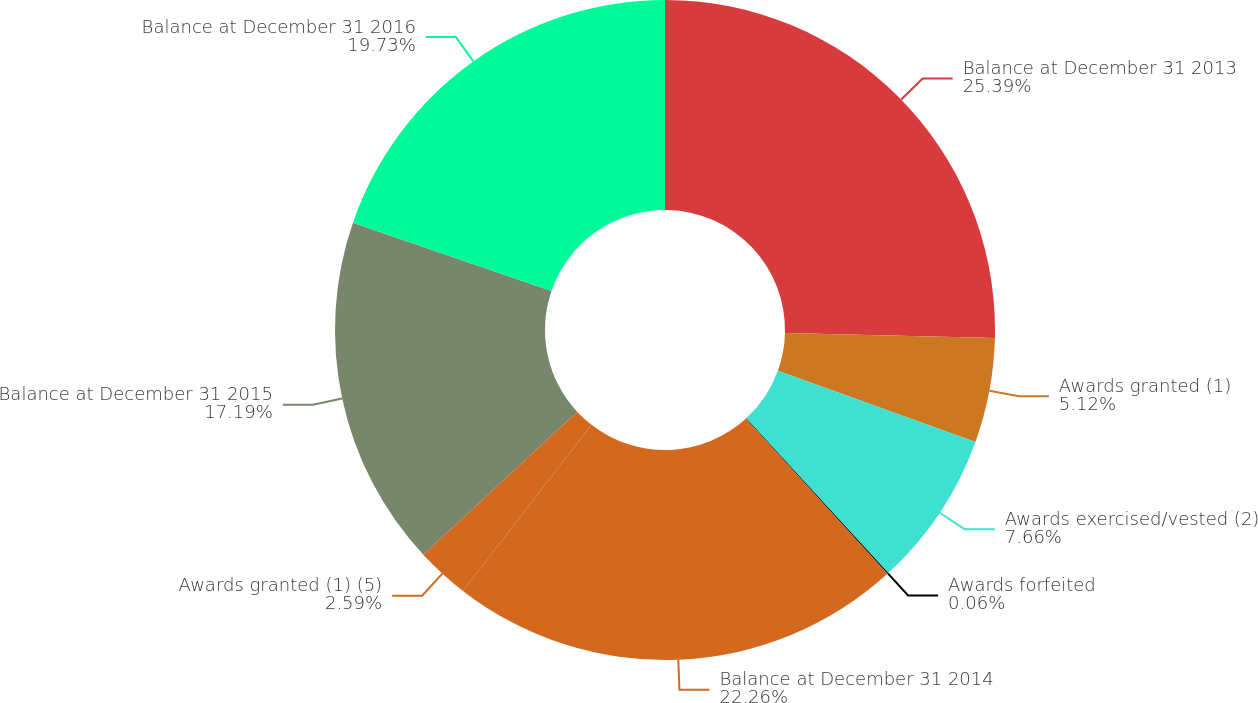Convert chart. <chart><loc_0><loc_0><loc_500><loc_500><pie_chart><fcel>Balance at December 31 2013<fcel>Awards granted (1)<fcel>Awards exercised/vested (2)<fcel>Awards forfeited<fcel>Balance at December 31 2014<fcel>Awards granted (1) (5)<fcel>Balance at December 31 2015<fcel>Balance at December 31 2016<nl><fcel>25.39%<fcel>5.12%<fcel>7.66%<fcel>0.06%<fcel>22.26%<fcel>2.59%<fcel>17.19%<fcel>19.73%<nl></chart> 